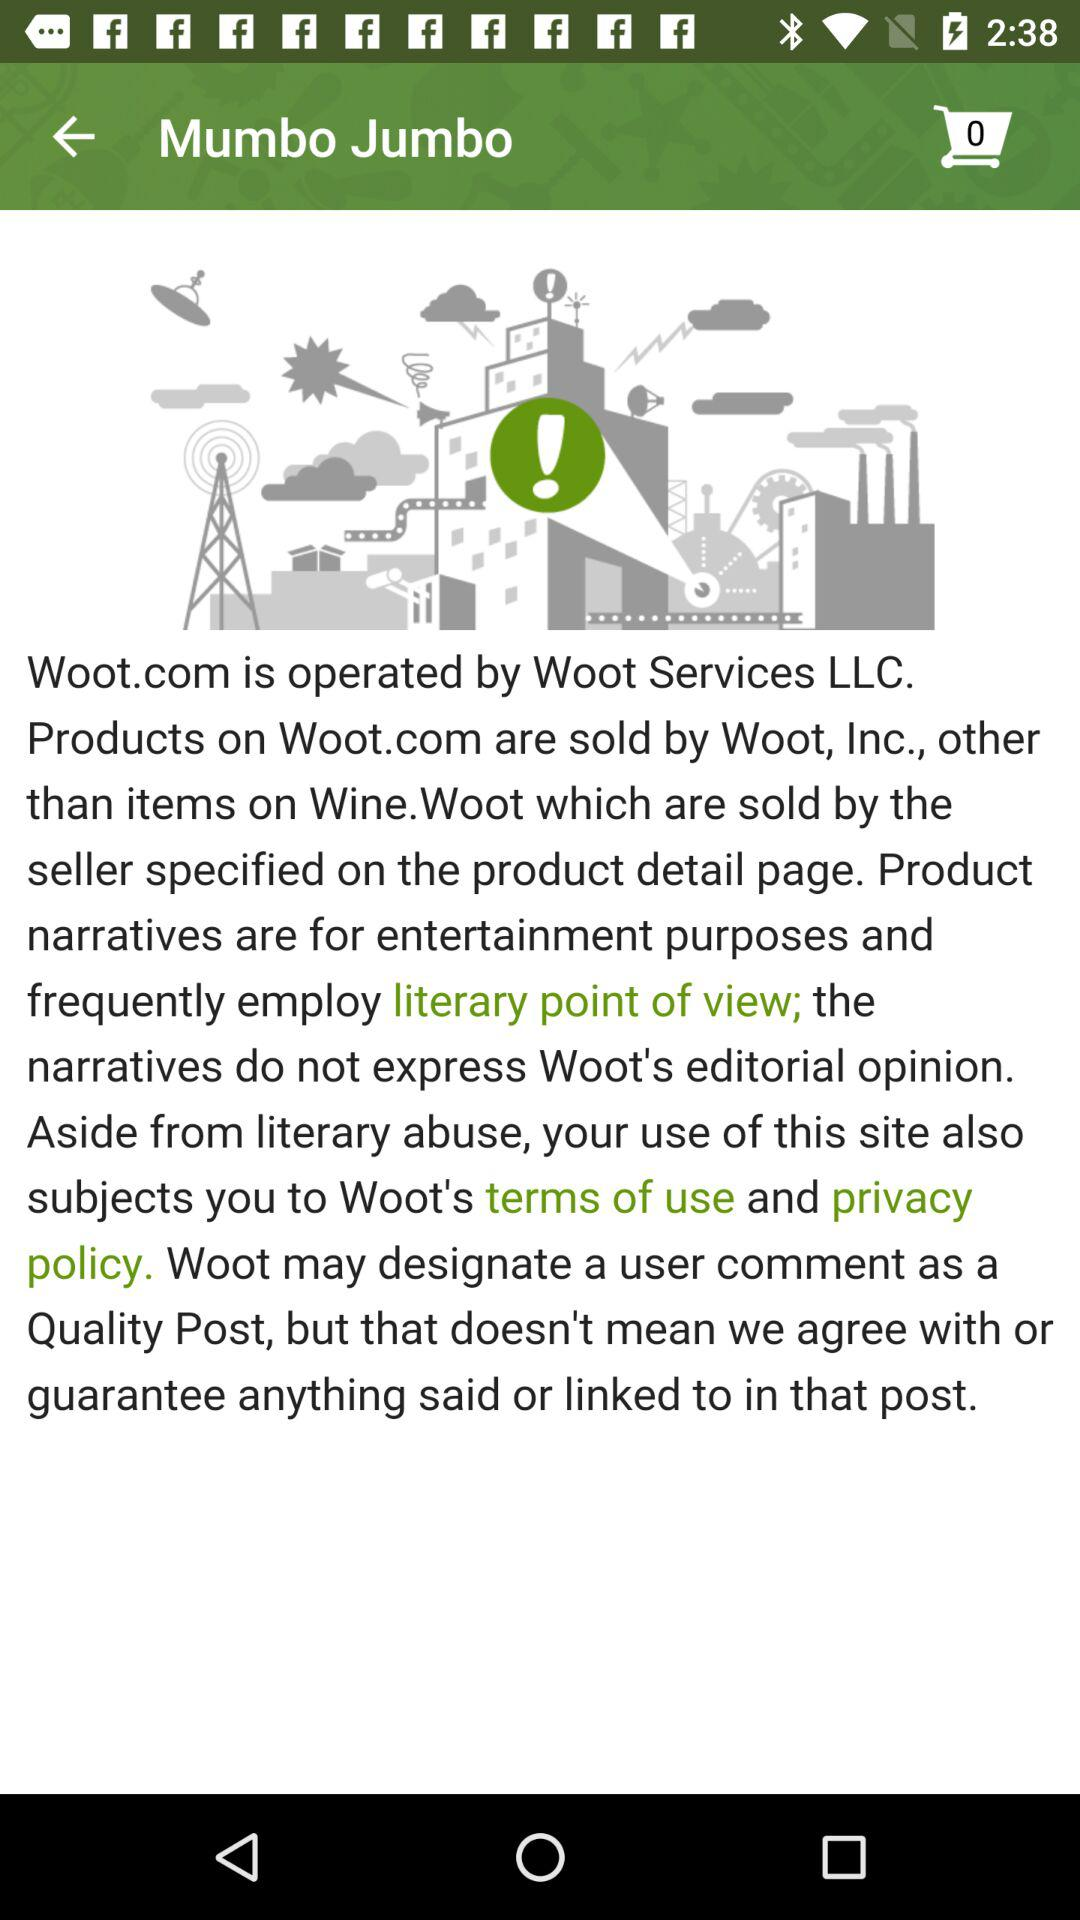What is the application name? The application name is "Mumbo Jumbo". 